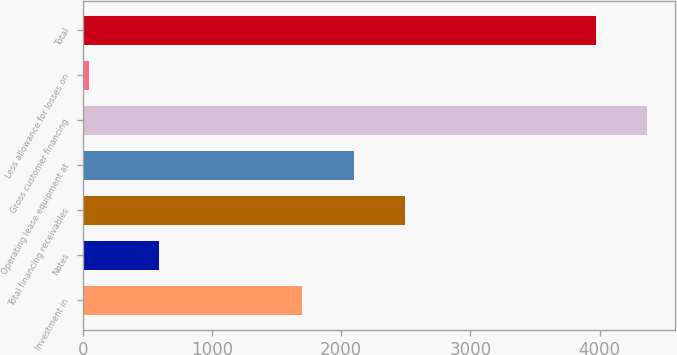Convert chart. <chart><loc_0><loc_0><loc_500><loc_500><bar_chart><fcel>Investment in<fcel>Notes<fcel>Total financing receivables<fcel>Operating lease equipment at<fcel>Gross customer financing<fcel>Less allowance for losses on<fcel>Total<nl><fcel>1699<fcel>587<fcel>2493.2<fcel>2096.1<fcel>4368.1<fcel>49<fcel>3971<nl></chart> 